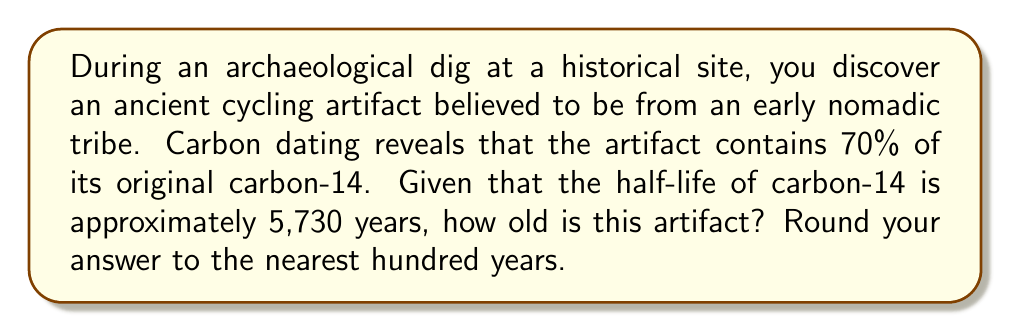Show me your answer to this math problem. Let's approach this step-by-step using the logarithmic decay formula:

1) The general formula for radioactive decay is:
   $$ N(t) = N_0 \cdot (0.5)^{t/t_{1/2}} $$
   Where:
   $N(t)$ is the amount remaining after time $t$
   $N_0$ is the initial amount
   $t_{1/2}$ is the half-life
   $t$ is the time elapsed

2) We know that 70% of the original carbon-14 remains, so:
   $$ 0.70 = (0.5)^{t/5730} $$

3) Taking the natural log of both sides:
   $$ \ln(0.70) = \ln((0.5)^{t/5730}) $$

4) Using the logarithm property $\ln(a^b) = b\ln(a)$:
   $$ \ln(0.70) = \frac{t}{5730} \ln(0.5) $$

5) Solving for $t$:
   $$ t = \frac{5730 \cdot \ln(0.70)}{\ln(0.5)} $$

6) Calculate:
   $$ t = \frac{5730 \cdot (-0.35667494)}{ (-0.69314718)} $$
   $$ t = 2944.8 \text{ years} $$

7) Rounding to the nearest hundred years:
   $$ t \approx 2900 \text{ years} $$
Answer: 2900 years 